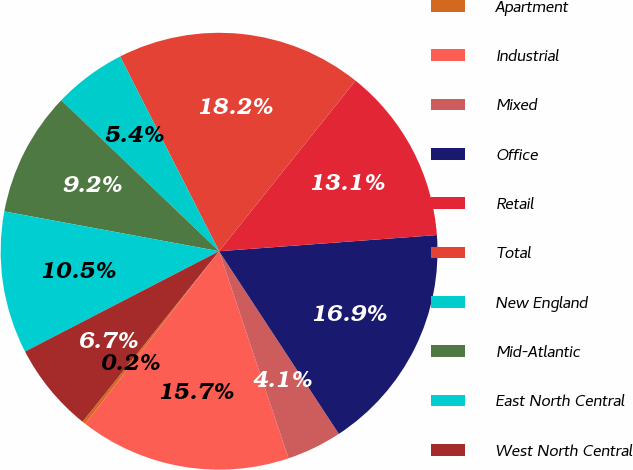Convert chart to OTSL. <chart><loc_0><loc_0><loc_500><loc_500><pie_chart><fcel>Apartment<fcel>Industrial<fcel>Mixed<fcel>Office<fcel>Retail<fcel>Total<fcel>New England<fcel>Mid-Atlantic<fcel>East North Central<fcel>West North Central<nl><fcel>0.24%<fcel>15.65%<fcel>4.09%<fcel>16.94%<fcel>13.08%<fcel>18.22%<fcel>5.37%<fcel>9.23%<fcel>10.51%<fcel>6.66%<nl></chart> 